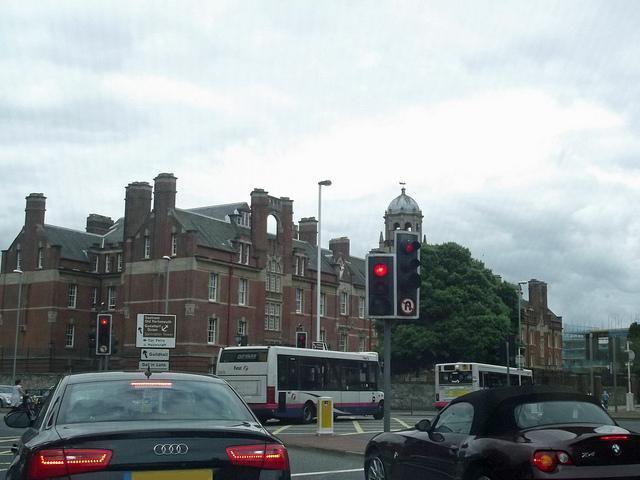What country are these cars manufactured in?
From the following four choices, select the correct answer to address the question.
Options: Poland, japan, usa, germany. Germany. 